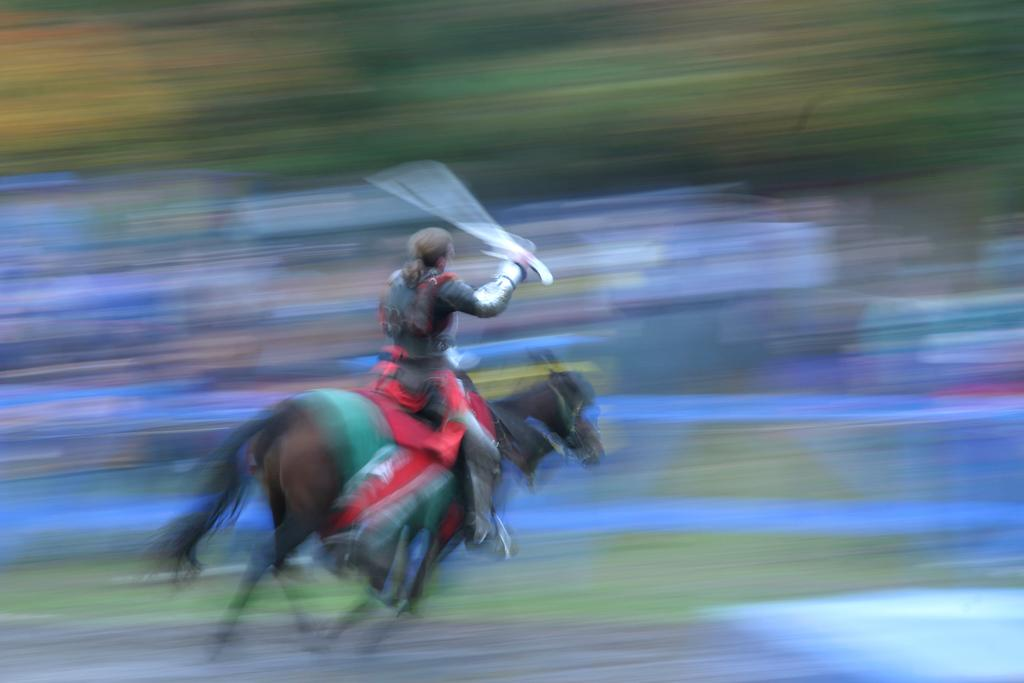What is the main subject of the image? The main subject of the image is a man. What is the man doing in the image? The man is riding a horse in the image. Where are the horse and rider located in the image? The horse and rider are on the left side of the image. Can you describe the background of the image? The background of the image is blurred. How many coats can be seen on the boat in the image? There is no boat or coat present in the image; it features a man riding a horse on the left side with a blurred background. 